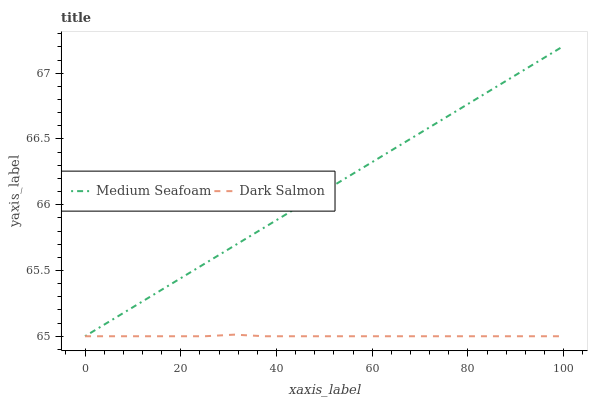Does Dark Salmon have the maximum area under the curve?
Answer yes or no. No. Is Dark Salmon the smoothest?
Answer yes or no. No. Does Dark Salmon have the highest value?
Answer yes or no. No. 